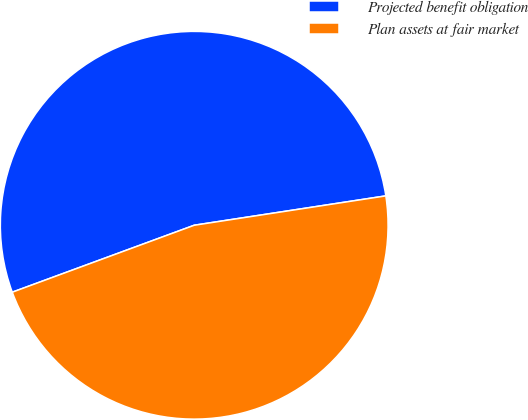Convert chart to OTSL. <chart><loc_0><loc_0><loc_500><loc_500><pie_chart><fcel>Projected benefit obligation<fcel>Plan assets at fair market<nl><fcel>53.19%<fcel>46.81%<nl></chart> 